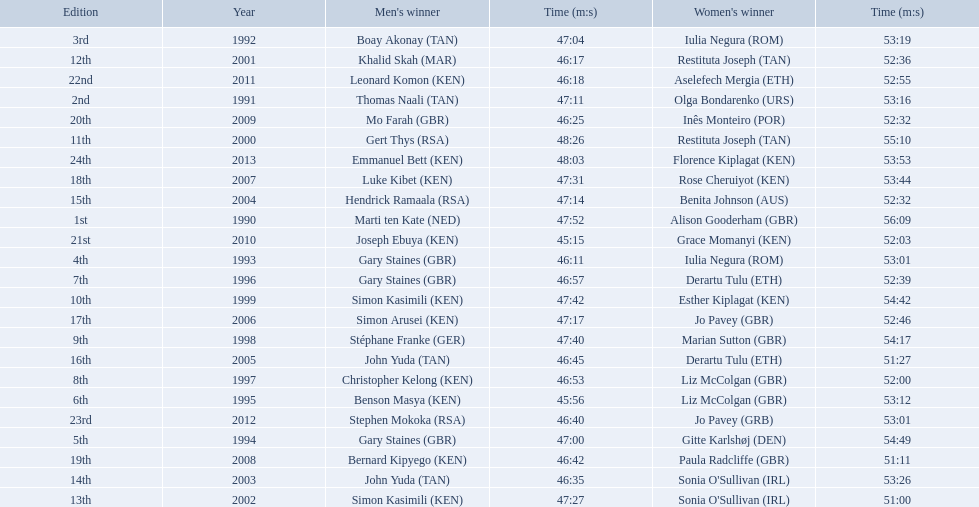Who were all the runners' times between 1990 and 2013? 47:52, 56:09, 47:11, 53:16, 47:04, 53:19, 46:11, 53:01, 47:00, 54:49, 45:56, 53:12, 46:57, 52:39, 46:53, 52:00, 47:40, 54:17, 47:42, 54:42, 48:26, 55:10, 46:17, 52:36, 47:27, 51:00, 46:35, 53:26, 47:14, 52:32, 46:45, 51:27, 47:17, 52:46, 47:31, 53:44, 46:42, 51:11, 46:25, 52:32, 45:15, 52:03, 46:18, 52:55, 46:40, 53:01, 48:03, 53:53. Which was the fastest time? 45:15. Parse the full table. {'header': ['Edition', 'Year', "Men's winner", 'Time (m:s)', "Women's winner", 'Time (m:s)'], 'rows': [['3rd', '1992', 'Boay Akonay\xa0(TAN)', '47:04', 'Iulia Negura\xa0(ROM)', '53:19'], ['12th', '2001', 'Khalid Skah\xa0(MAR)', '46:17', 'Restituta Joseph\xa0(TAN)', '52:36'], ['22nd', '2011', 'Leonard Komon\xa0(KEN)', '46:18', 'Aselefech Mergia\xa0(ETH)', '52:55'], ['2nd', '1991', 'Thomas Naali\xa0(TAN)', '47:11', 'Olga Bondarenko\xa0(URS)', '53:16'], ['20th', '2009', 'Mo Farah\xa0(GBR)', '46:25', 'Inês Monteiro\xa0(POR)', '52:32'], ['11th', '2000', 'Gert Thys\xa0(RSA)', '48:26', 'Restituta Joseph\xa0(TAN)', '55:10'], ['24th', '2013', 'Emmanuel Bett\xa0(KEN)', '48:03', 'Florence Kiplagat\xa0(KEN)', '53:53'], ['18th', '2007', 'Luke Kibet\xa0(KEN)', '47:31', 'Rose Cheruiyot\xa0(KEN)', '53:44'], ['15th', '2004', 'Hendrick Ramaala\xa0(RSA)', '47:14', 'Benita Johnson\xa0(AUS)', '52:32'], ['1st', '1990', 'Marti ten Kate\xa0(NED)', '47:52', 'Alison Gooderham\xa0(GBR)', '56:09'], ['21st', '2010', 'Joseph Ebuya\xa0(KEN)', '45:15', 'Grace Momanyi\xa0(KEN)', '52:03'], ['4th', '1993', 'Gary Staines\xa0(GBR)', '46:11', 'Iulia Negura\xa0(ROM)', '53:01'], ['7th', '1996', 'Gary Staines\xa0(GBR)', '46:57', 'Derartu Tulu\xa0(ETH)', '52:39'], ['10th', '1999', 'Simon Kasimili\xa0(KEN)', '47:42', 'Esther Kiplagat\xa0(KEN)', '54:42'], ['17th', '2006', 'Simon Arusei\xa0(KEN)', '47:17', 'Jo Pavey\xa0(GBR)', '52:46'], ['9th', '1998', 'Stéphane Franke\xa0(GER)', '47:40', 'Marian Sutton\xa0(GBR)', '54:17'], ['16th', '2005', 'John Yuda\xa0(TAN)', '46:45', 'Derartu Tulu\xa0(ETH)', '51:27'], ['8th', '1997', 'Christopher Kelong\xa0(KEN)', '46:53', 'Liz McColgan\xa0(GBR)', '52:00'], ['6th', '1995', 'Benson Masya\xa0(KEN)', '45:56', 'Liz McColgan\xa0(GBR)', '53:12'], ['23rd', '2012', 'Stephen Mokoka\xa0(RSA)', '46:40', 'Jo Pavey\xa0(GRB)', '53:01'], ['5th', '1994', 'Gary Staines\xa0(GBR)', '47:00', 'Gitte Karlshøj\xa0(DEN)', '54:49'], ['19th', '2008', 'Bernard Kipyego\xa0(KEN)', '46:42', 'Paula Radcliffe\xa0(GBR)', '51:11'], ['14th', '2003', 'John Yuda\xa0(TAN)', '46:35', "Sonia O'Sullivan\xa0(IRL)", '53:26'], ['13th', '2002', 'Simon Kasimili\xa0(KEN)', '47:27', "Sonia O'Sullivan\xa0(IRL)", '51:00']]} Who ran that time? Joseph Ebuya (KEN). 